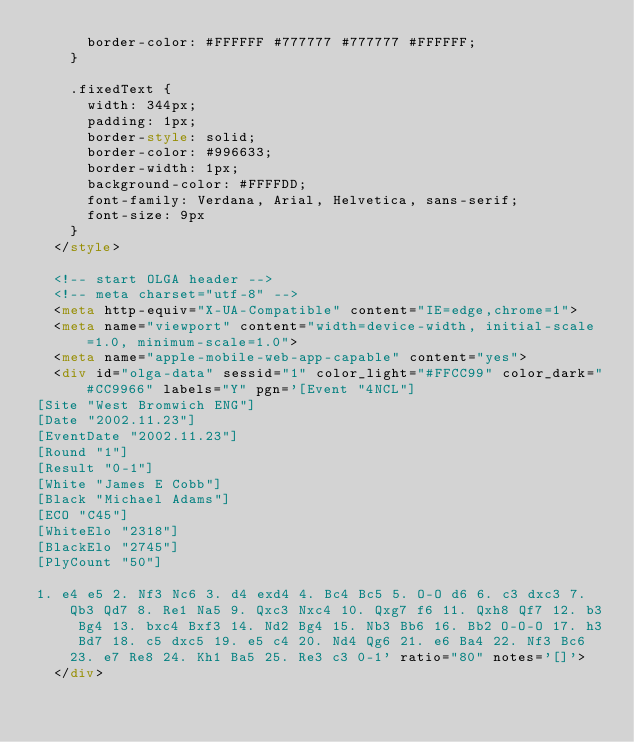Convert code to text. <code><loc_0><loc_0><loc_500><loc_500><_HTML_>      border-color: #FFFFFF #777777 #777777 #FFFFFF;
    }

    .fixedText {
      width: 344px;
      padding: 1px;
      border-style: solid;
      border-color: #996633;
      border-width: 1px;
      background-color: #FFFFDD;
      font-family: Verdana, Arial, Helvetica, sans-serif;
      font-size: 9px
    }
  </style>

  <!-- start OLGA header -->
  <!-- meta charset="utf-8" -->
  <meta http-equiv="X-UA-Compatible" content="IE=edge,chrome=1">
  <meta name="viewport" content="width=device-width, initial-scale=1.0, minimum-scale=1.0">
  <meta name="apple-mobile-web-app-capable" content="yes">
  <div id="olga-data" sessid="1" color_light="#FFCC99" color_dark="#CC9966" labels="Y" pgn='[Event "4NCL"]
[Site "West Bromwich ENG"]
[Date "2002.11.23"]
[EventDate "2002.11.23"]
[Round "1"]
[Result "0-1"]
[White "James E Cobb"]
[Black "Michael Adams"]
[ECO "C45"]
[WhiteElo "2318"]
[BlackElo "2745"]
[PlyCount "50"]

1. e4 e5 2. Nf3 Nc6 3. d4 exd4 4. Bc4 Bc5 5. O-O d6 6. c3 dxc3 7. Qb3 Qd7 8. Re1 Na5 9. Qxc3 Nxc4 10. Qxg7 f6 11. Qxh8 Qf7 12. b3 Bg4 13. bxc4 Bxf3 14. Nd2 Bg4 15. Nb3 Bb6 16. Bb2 O-O-O 17. h3 Bd7 18. c5 dxc5 19. e5 c4 20. Nd4 Qg6 21. e6 Ba4 22. Nf3 Bc6 23. e7 Re8 24. Kh1 Ba5 25. Re3 c3 0-1' ratio="80" notes='[]'>
  </div></code> 